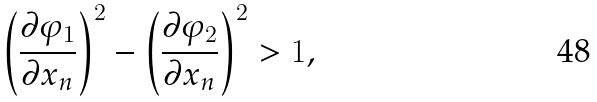Convert formula to latex. <formula><loc_0><loc_0><loc_500><loc_500>\left ( \frac { \partial \varphi _ { 1 } } { \partial x _ { n } } \right ) ^ { 2 } - \left ( \frac { \partial \varphi _ { 2 } } { \partial x _ { n } } \right ) ^ { 2 } > 1 ,</formula> 